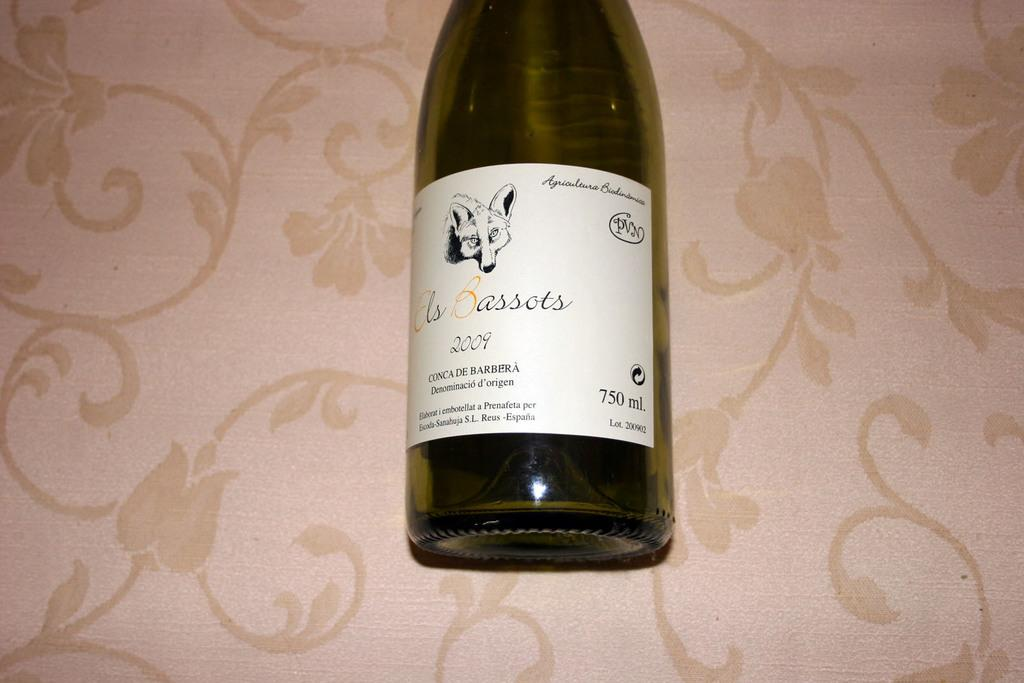What object can be seen in the image? There is a bottle in the image. Where is the bottle located? The bottle is placed on a table. What type of border is visible around the bottle in the image? There is no border visible around the bottle in the image. 